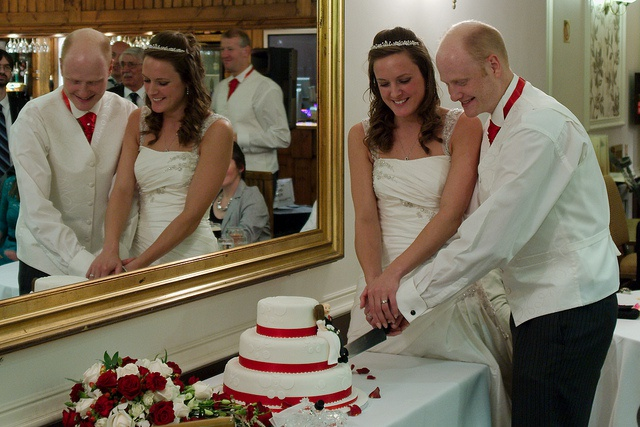Describe the objects in this image and their specific colors. I can see people in maroon, darkgray, black, gray, and brown tones, people in maroon, darkgray, brown, black, and gray tones, people in maroon, brown, black, and darkgray tones, people in maroon, darkgray, and gray tones, and cake in maroon, darkgray, and black tones in this image. 